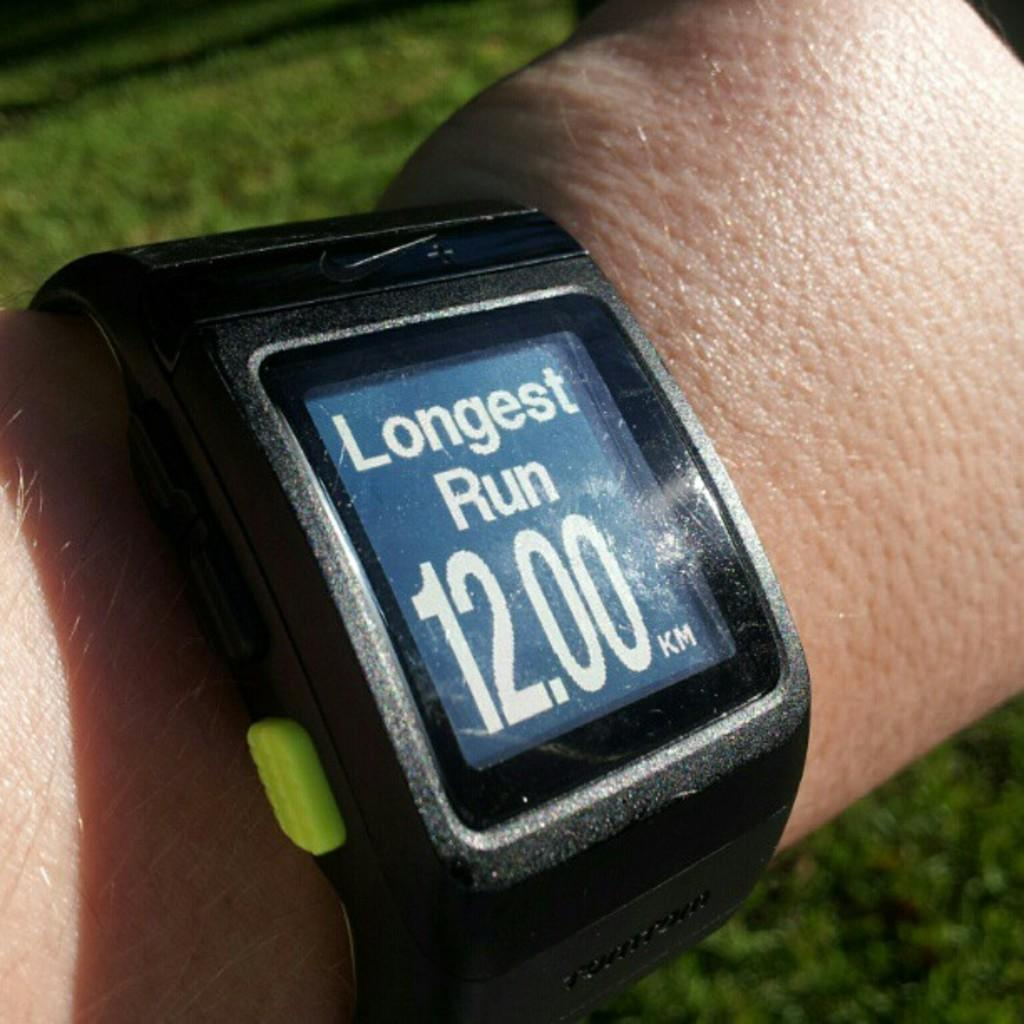Provide a one-sentence caption for the provided image. A watch showing the longest run at 12 kilometers. 